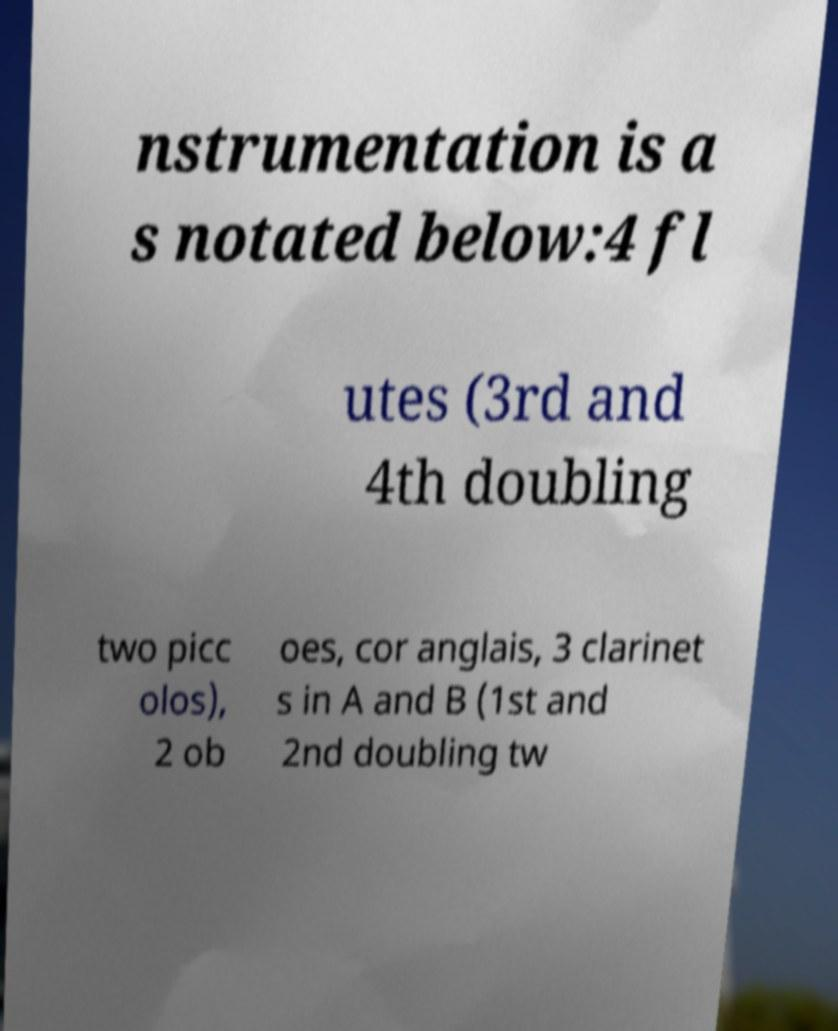Can you read and provide the text displayed in the image?This photo seems to have some interesting text. Can you extract and type it out for me? nstrumentation is a s notated below:4 fl utes (3rd and 4th doubling two picc olos), 2 ob oes, cor anglais, 3 clarinet s in A and B (1st and 2nd doubling tw 